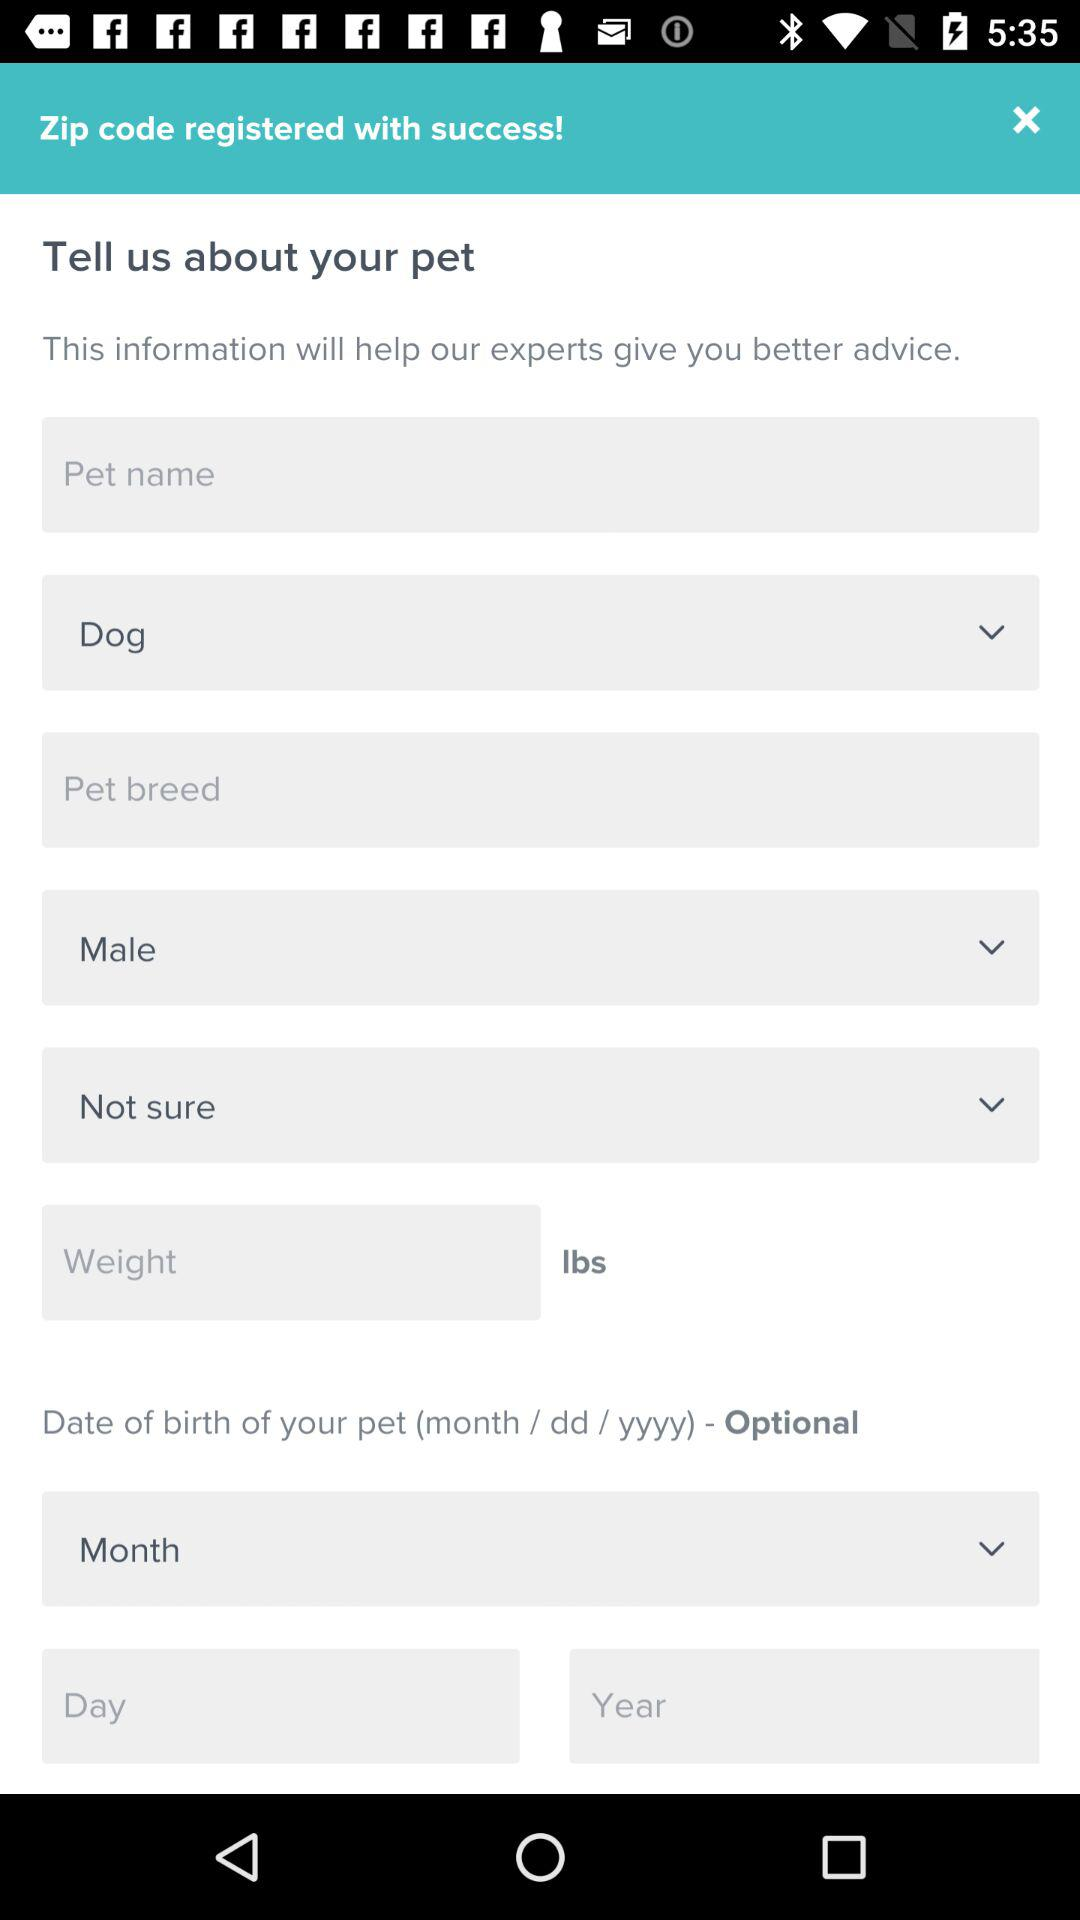What is the birthdate pattern here? The birthdate pattern here is "month / dd / yyyy". 